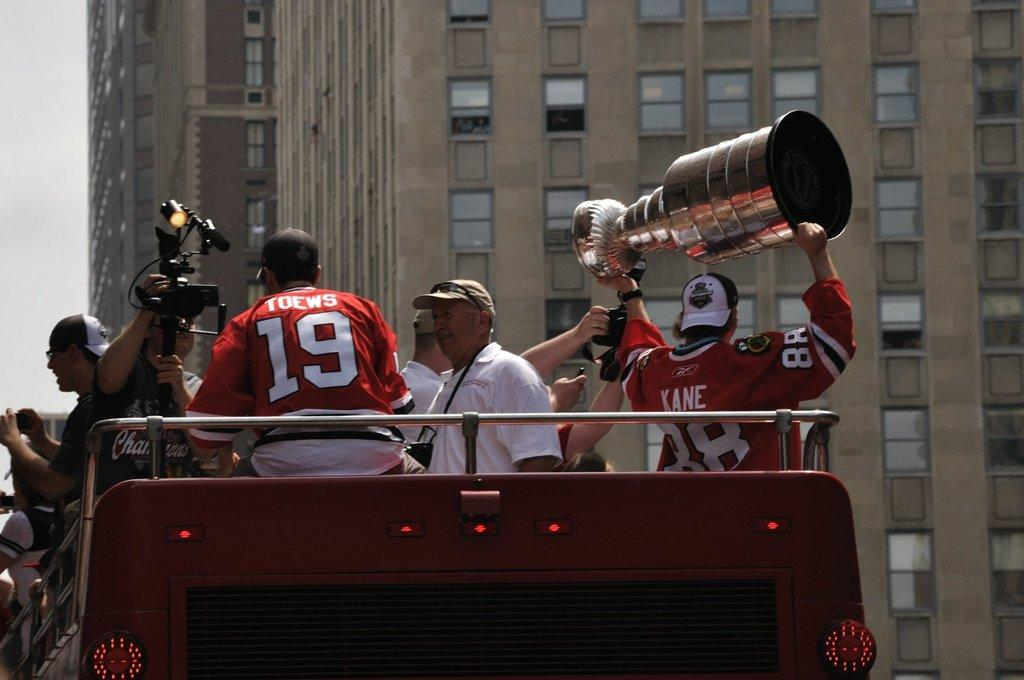<image>
Write a terse but informative summary of the picture. Man wearing a jersey saying Kane holding up a trophy. 